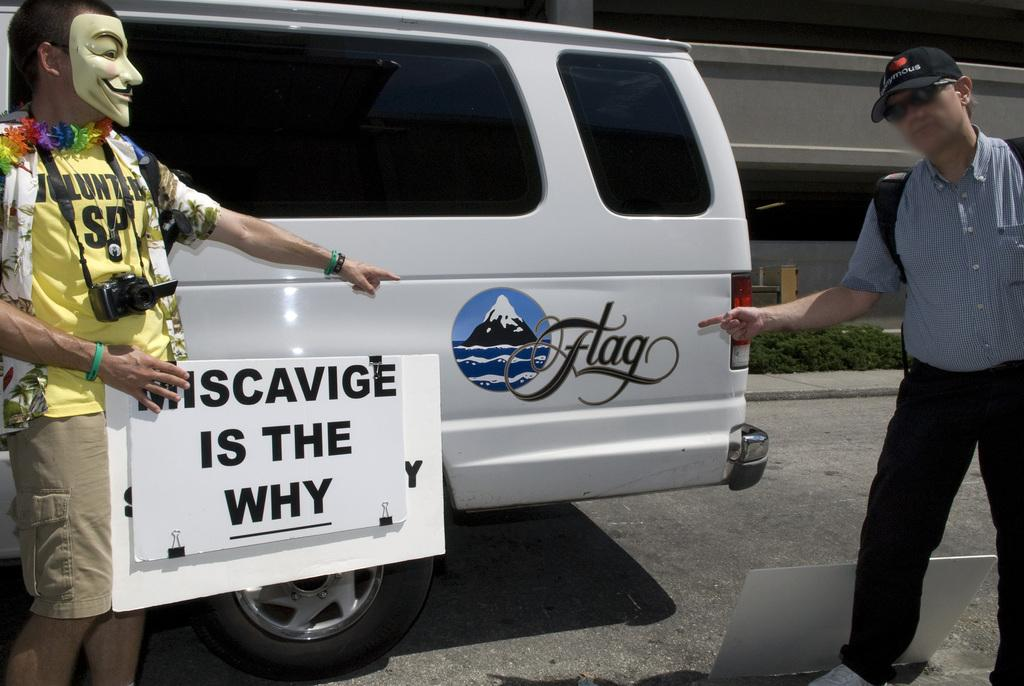Provide a one-sentence caption for the provided image. A man holding a miscavige is the why sign pointing to another man. 